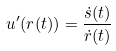Convert formula to latex. <formula><loc_0><loc_0><loc_500><loc_500>u ^ { \prime } ( r ( t ) ) = \frac { \dot { s } ( t ) } { \dot { r } ( t ) }</formula> 